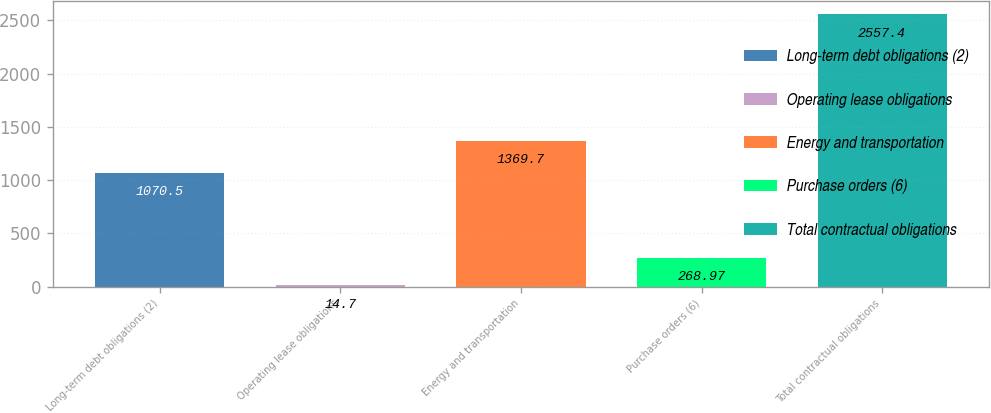<chart> <loc_0><loc_0><loc_500><loc_500><bar_chart><fcel>Long-term debt obligations (2)<fcel>Operating lease obligations<fcel>Energy and transportation<fcel>Purchase orders (6)<fcel>Total contractual obligations<nl><fcel>1070.5<fcel>14.7<fcel>1369.7<fcel>268.97<fcel>2557.4<nl></chart> 